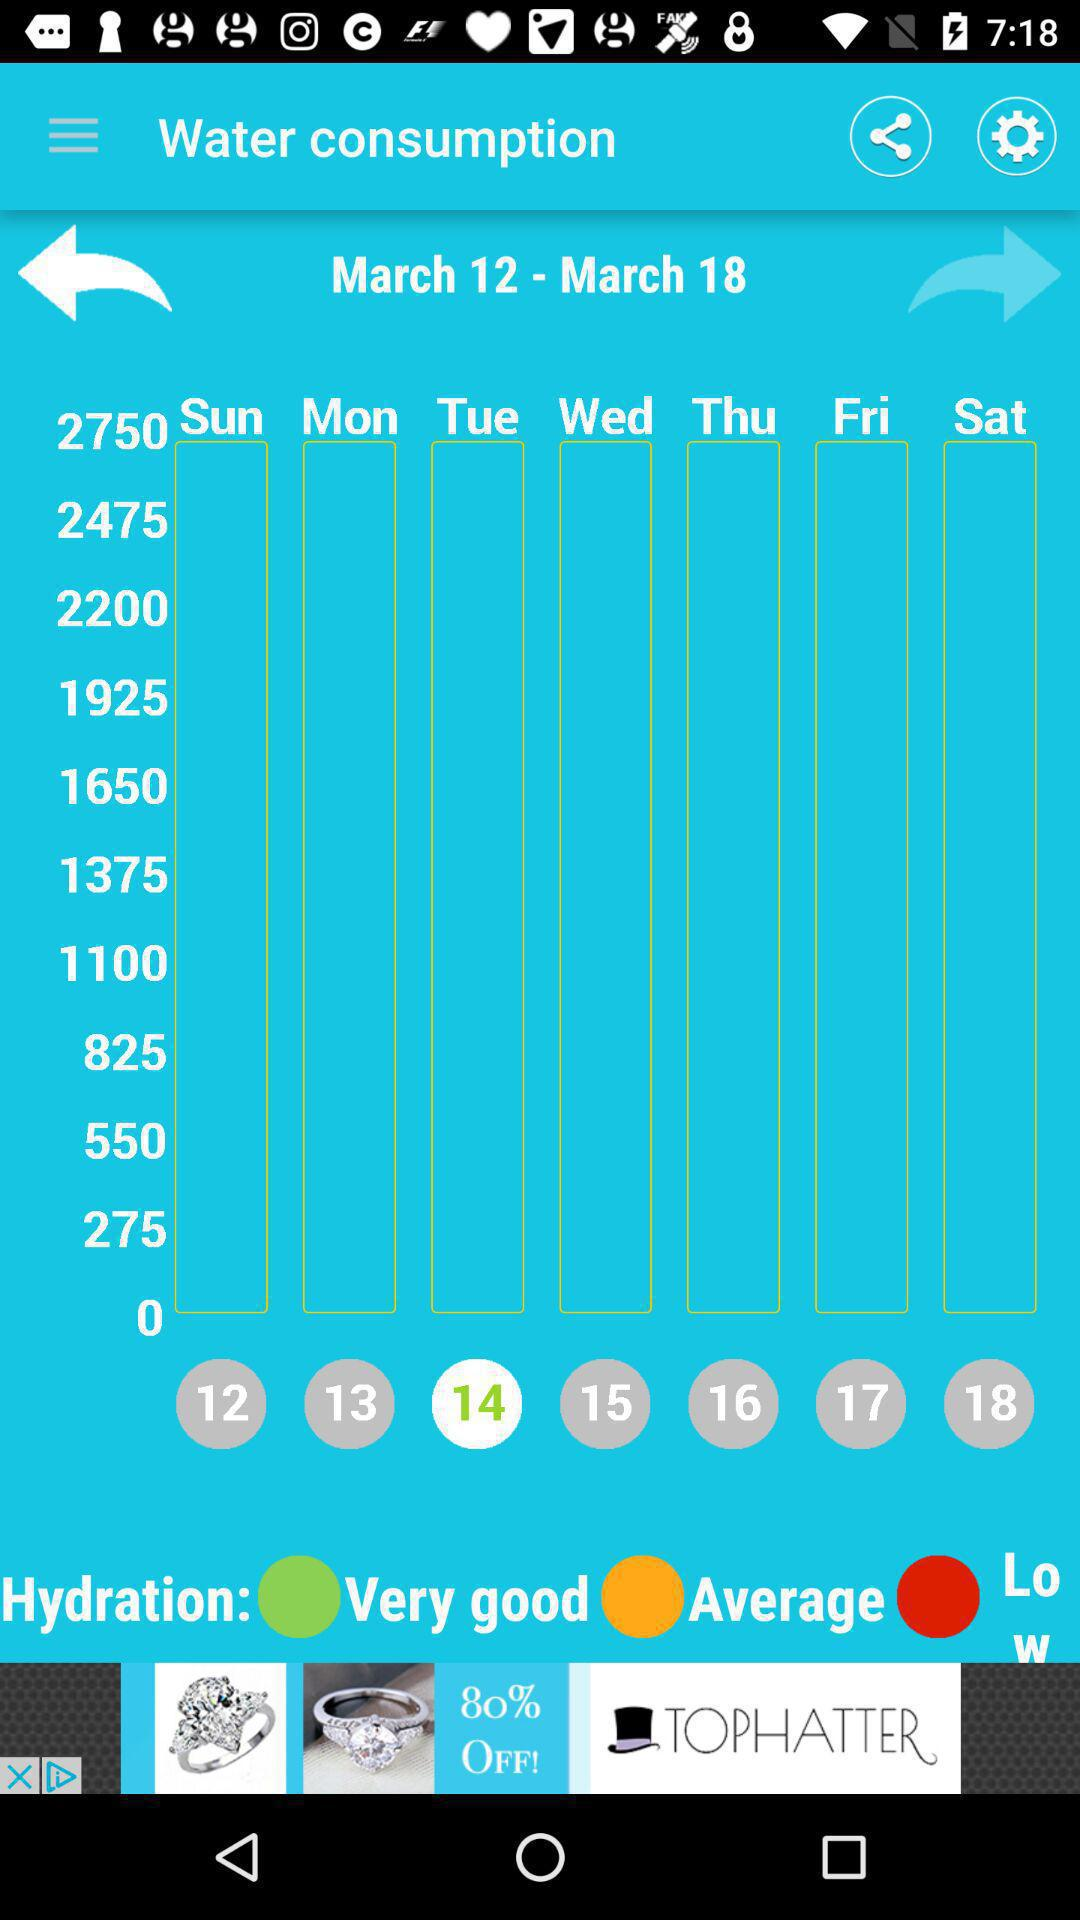What is the selected date range? The selected date range is March 12–March 18. 